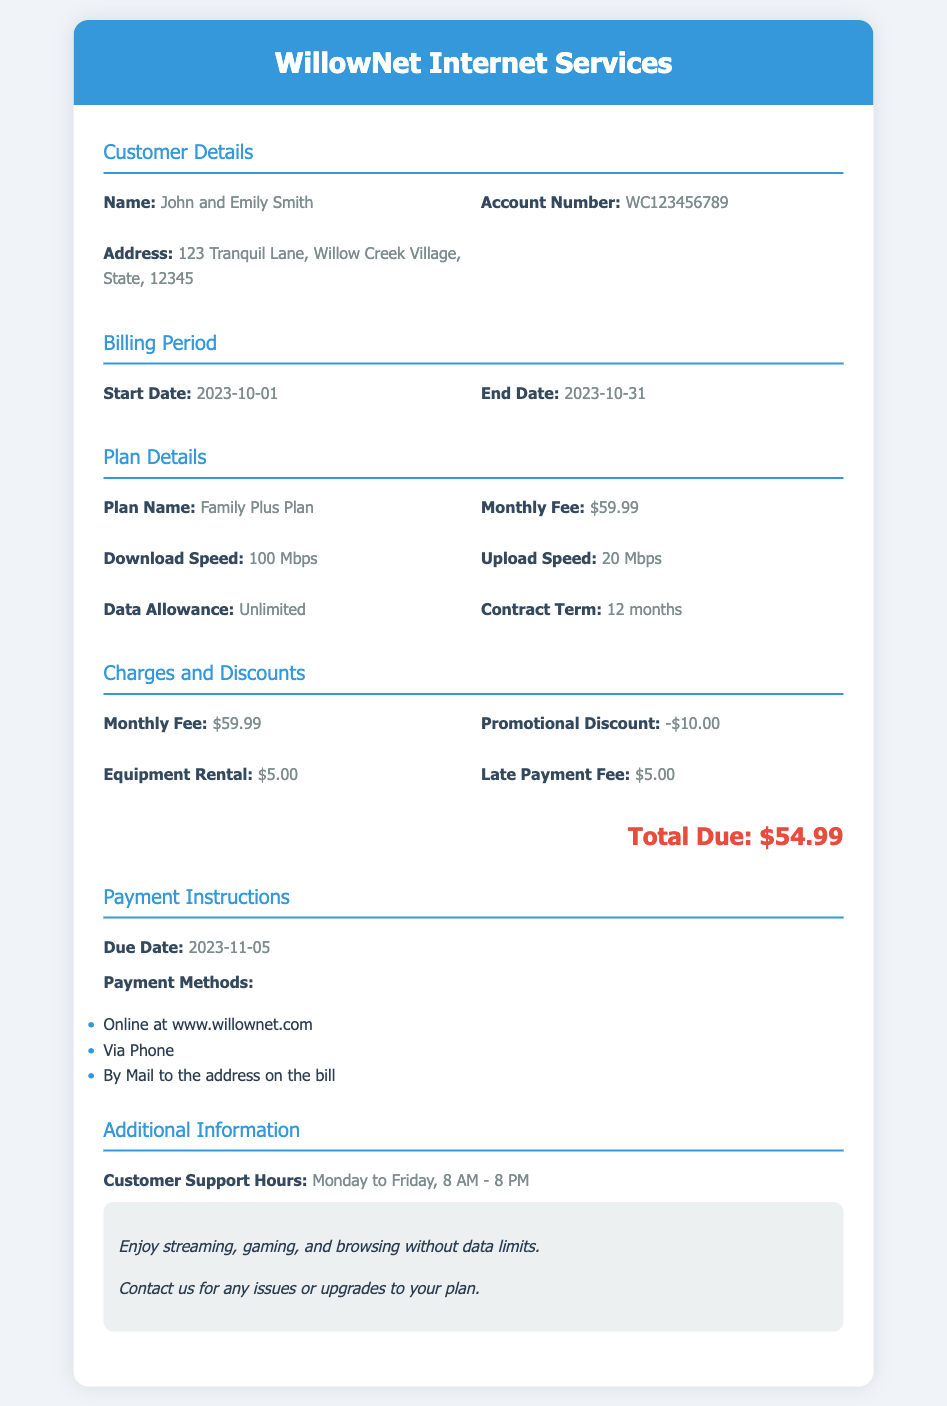What is the name on the account? The name on the account is specified in the customer details section of the document.
Answer: John and Emily Smith What is the total due amount? The total due is listed under the charges and discounts section in the document.
Answer: $54.99 What is the monthly fee for the plan? The monthly fee is found in the plan details section of the document.
Answer: $59.99 What is the upload speed? The upload speed is indicated in the plan details section of the document.
Answer: 20 Mbps What is the promotional discount amount? The promotional discount is detailed in the charges and discounts section of the document.
Answer: -$10.00 When is the due date for the payment? The due date is stated in the payment instructions section of the document.
Answer: 2023-11-05 Which plan is selected? The plan name is listed in the plan details section of the document.
Answer: Family Plus Plan What is included in the data allowance? The data allowance information is provided in the plan details section and includes specifics about the plan.
Answer: Unlimited What are the customer support hours? The customer support hours are noted in the additional information section of the document.
Answer: Monday to Friday, 8 AM - 8 PM 